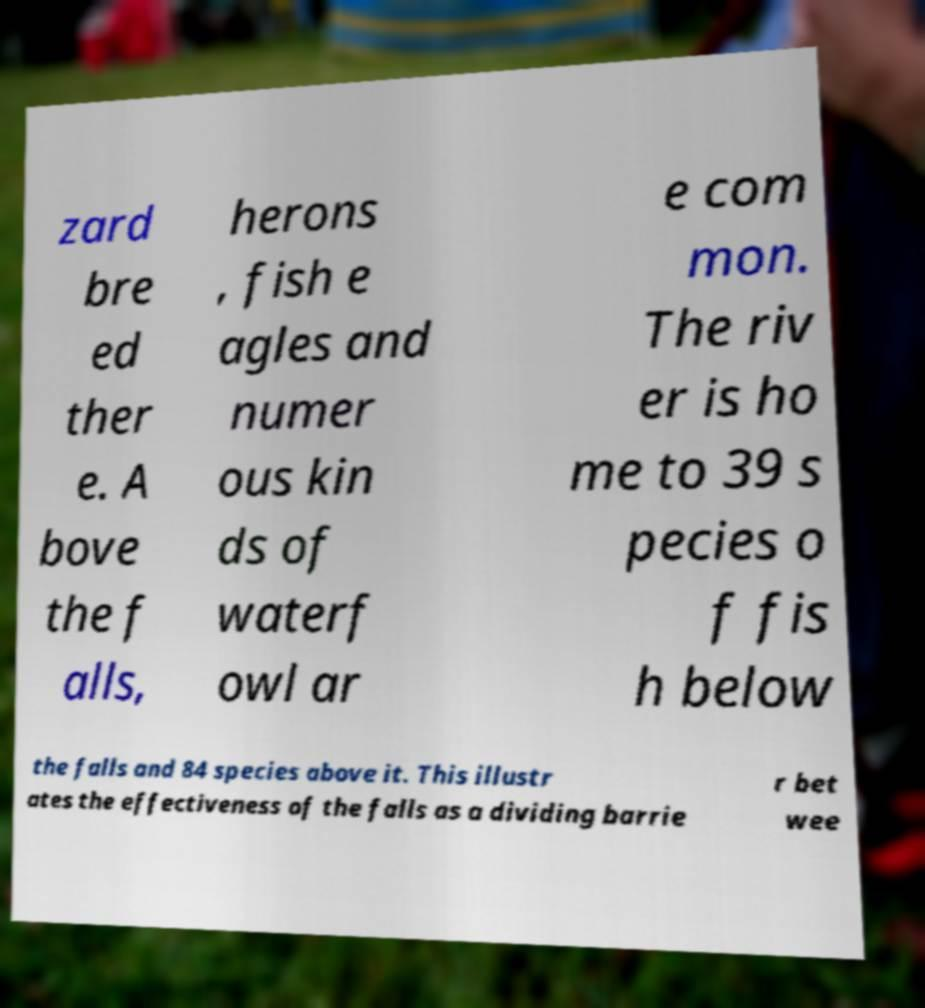Can you accurately transcribe the text from the provided image for me? zard bre ed ther e. A bove the f alls, herons , fish e agles and numer ous kin ds of waterf owl ar e com mon. The riv er is ho me to 39 s pecies o f fis h below the falls and 84 species above it. This illustr ates the effectiveness of the falls as a dividing barrie r bet wee 